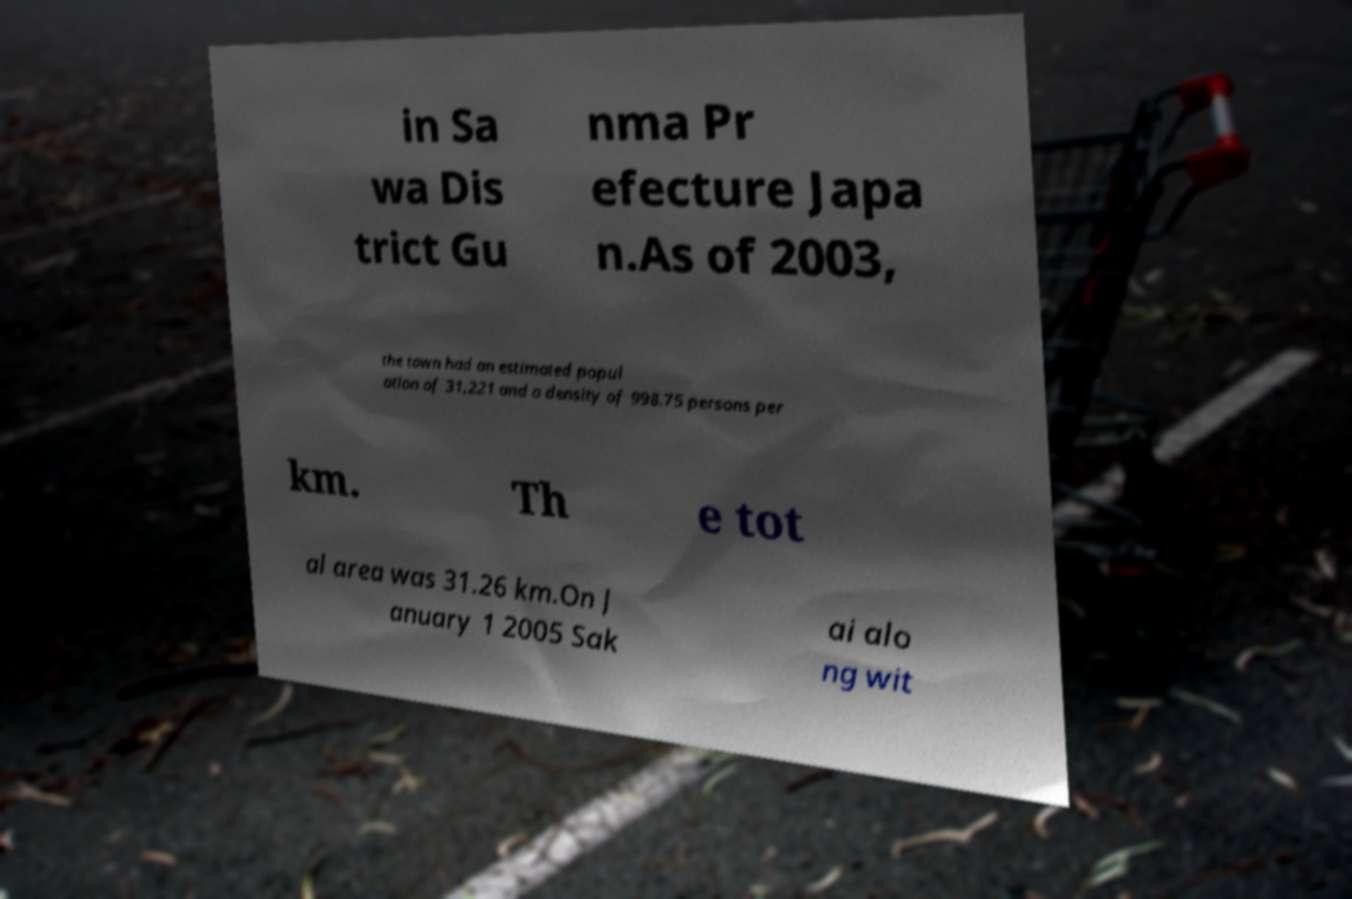Could you extract and type out the text from this image? in Sa wa Dis trict Gu nma Pr efecture Japa n.As of 2003, the town had an estimated popul ation of 31,221 and a density of 998.75 persons per km. Th e tot al area was 31.26 km.On J anuary 1 2005 Sak ai alo ng wit 